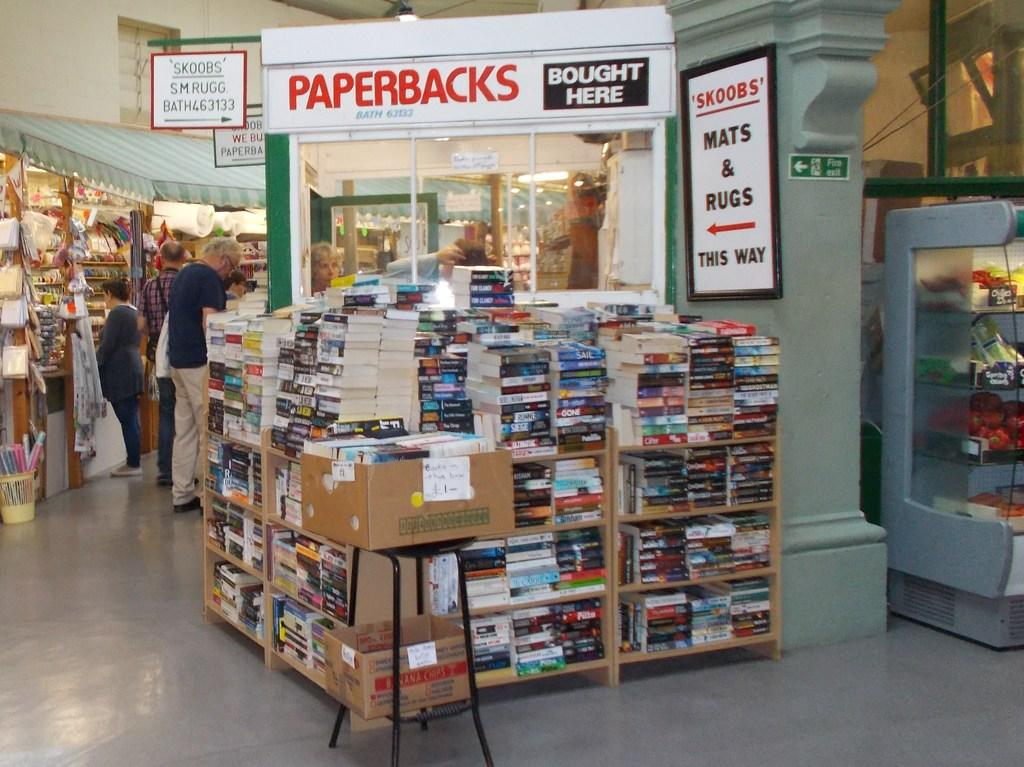<image>
Write a terse but informative summary of the picture. large stacks of books in front of paperbacks bought here sign 